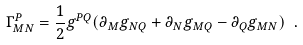Convert formula to latex. <formula><loc_0><loc_0><loc_500><loc_500>\Gamma ^ { P } _ { M N } = \frac { 1 } { 2 } g ^ { P Q } ( \partial _ { M } g _ { N Q } + \partial _ { N } g _ { M Q } - \partial _ { Q } g _ { M N } ) \ .</formula> 